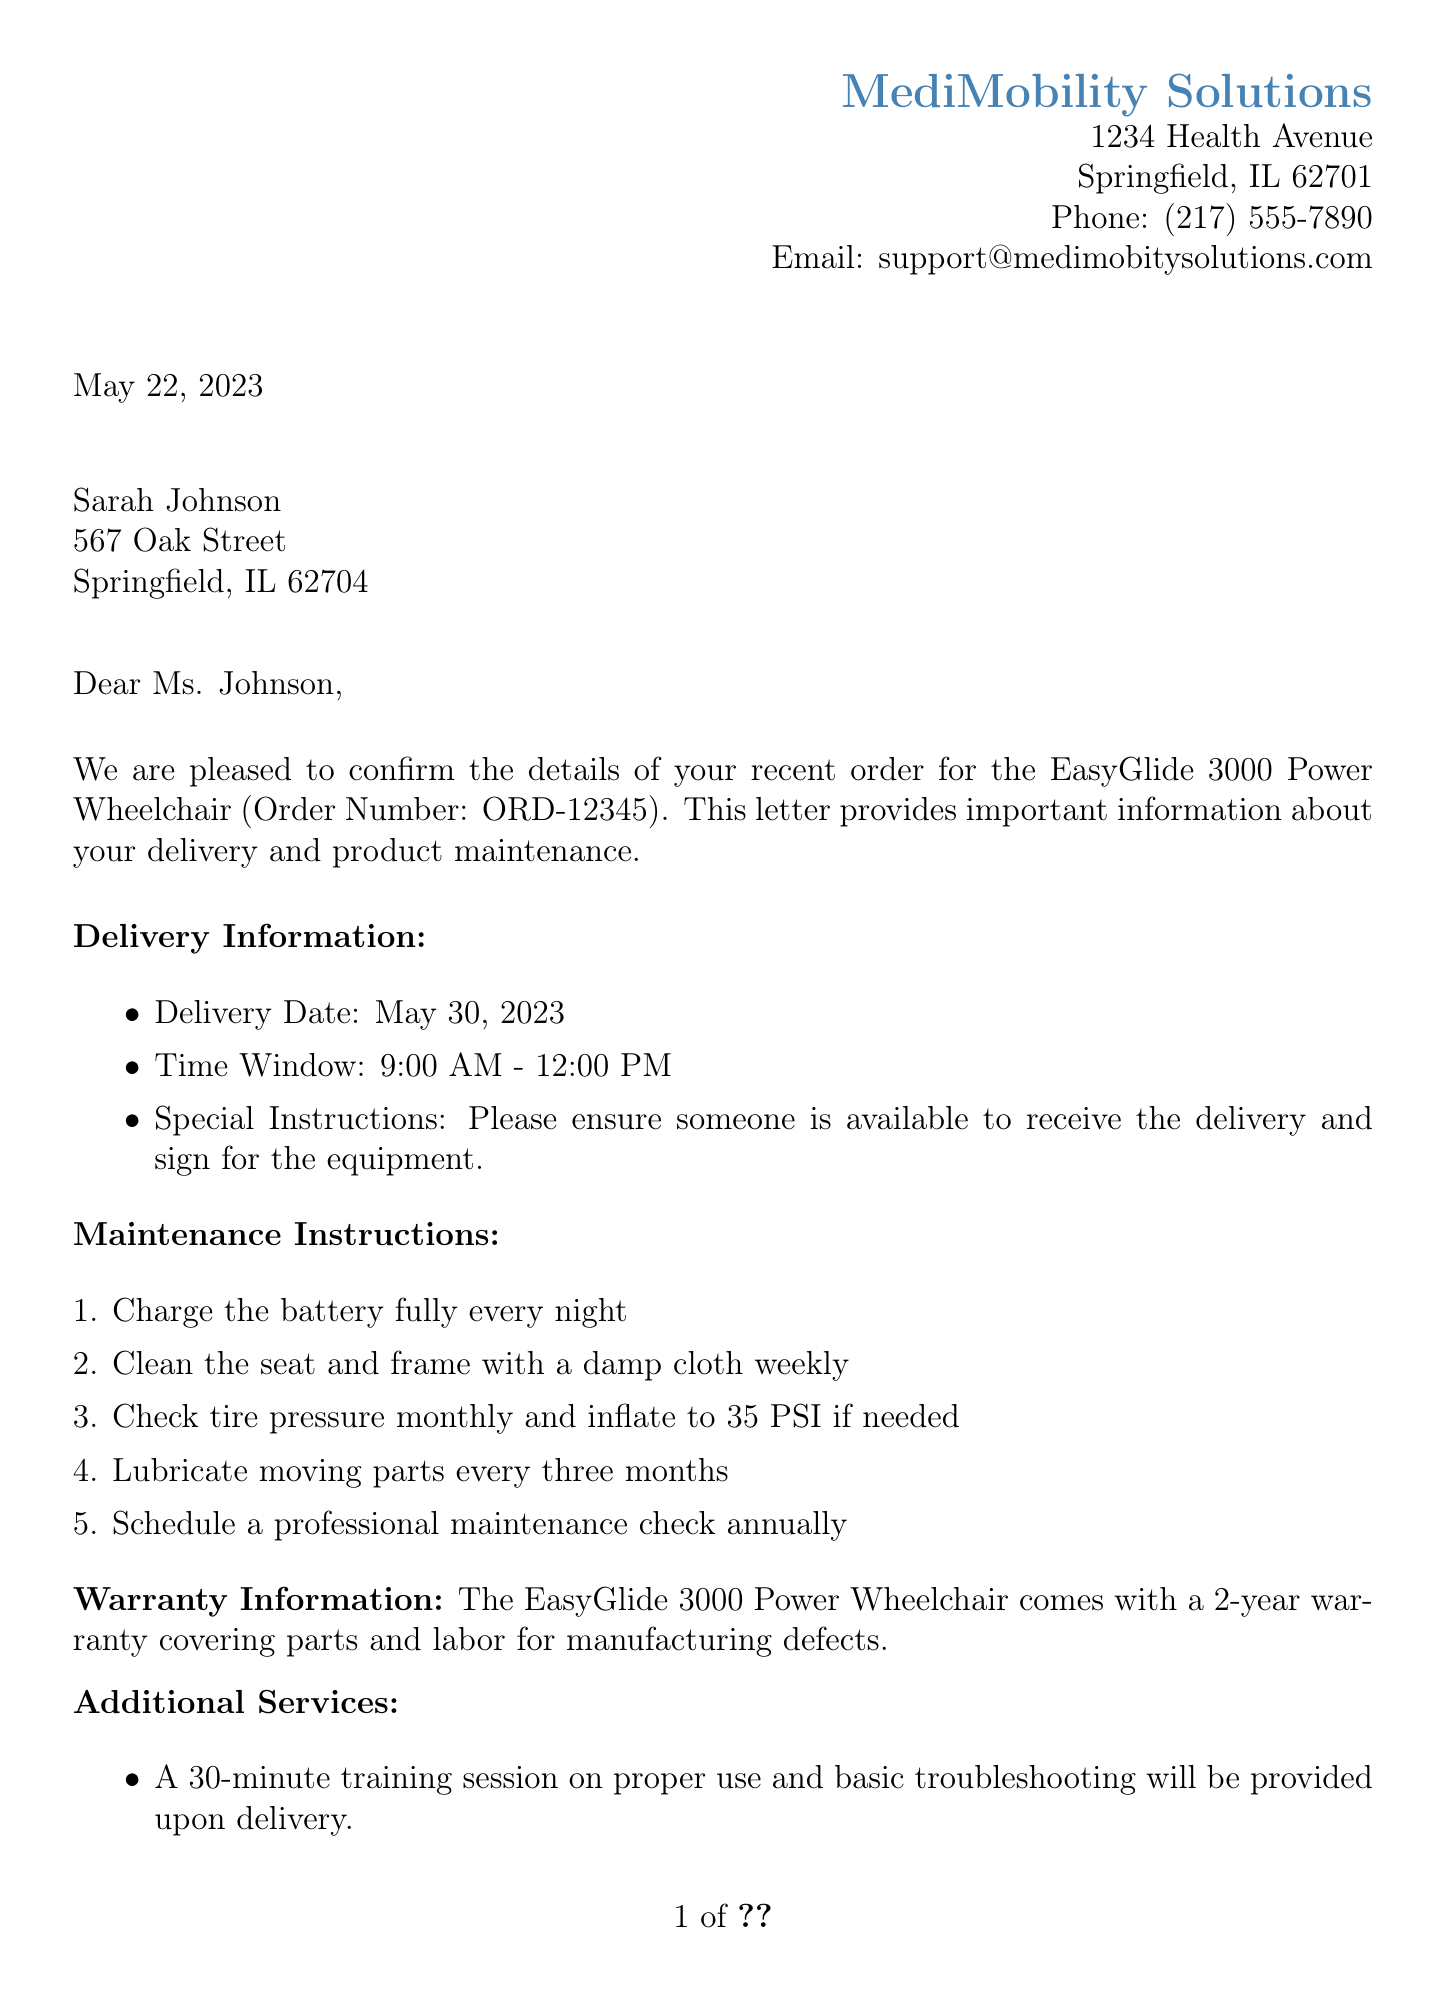What is the company name? The company name mentioned in the document is the supplier's name, which is found in the header.
Answer: MediMobility Solutions What is the delivery date? The delivery date is a specific date provided in the delivery information section of the document.
Answer: May 30, 2023 What is the warranty duration? The warranty duration is specified in the warranty information section and must be accurately retrieved from that part of the document.
Answer: 2 years What are the payment method details? The payment method describes how the payment is to be made, which is noted in the payment information section.
Answer: Insurance claim (Medicare) What is the total amount due? The total amount due is listed in the payment information section of the document as the total charge for the product.
Answer: $3,499.99 What is included in the maintenance instructions? Maintenance instructions detail specific care tasks that need to be performed, and these items can be found in the relevant section of the document.
Answer: Charge the battery fully every night What should be done to the wheelchair monthly? This question requires reasoning based on the maintenance instructions provided in the document, asking for regular maintenance tasks.
Answer: Check tire pressure Who is the customer support contact? The name of the customer support contact is stated in the support contact section, making it easy to find this person's details.
Answer: John Smith What is the copay amount? The copay amount is listed in the payment information section, providing a specific financial figure to be addressed.
Answer: $175.00 